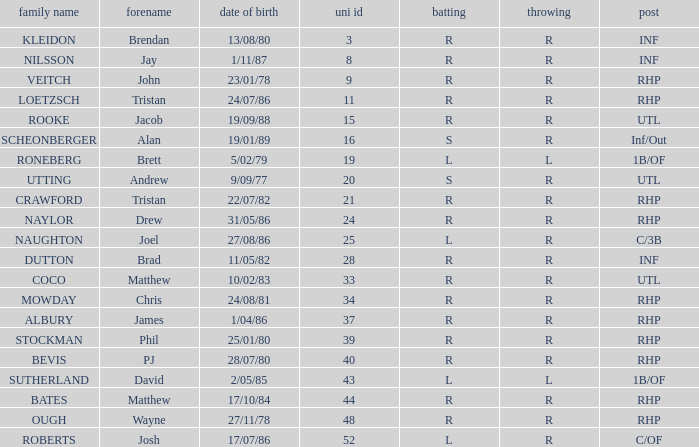Which Uni # has a Surname of ough? 48.0. 